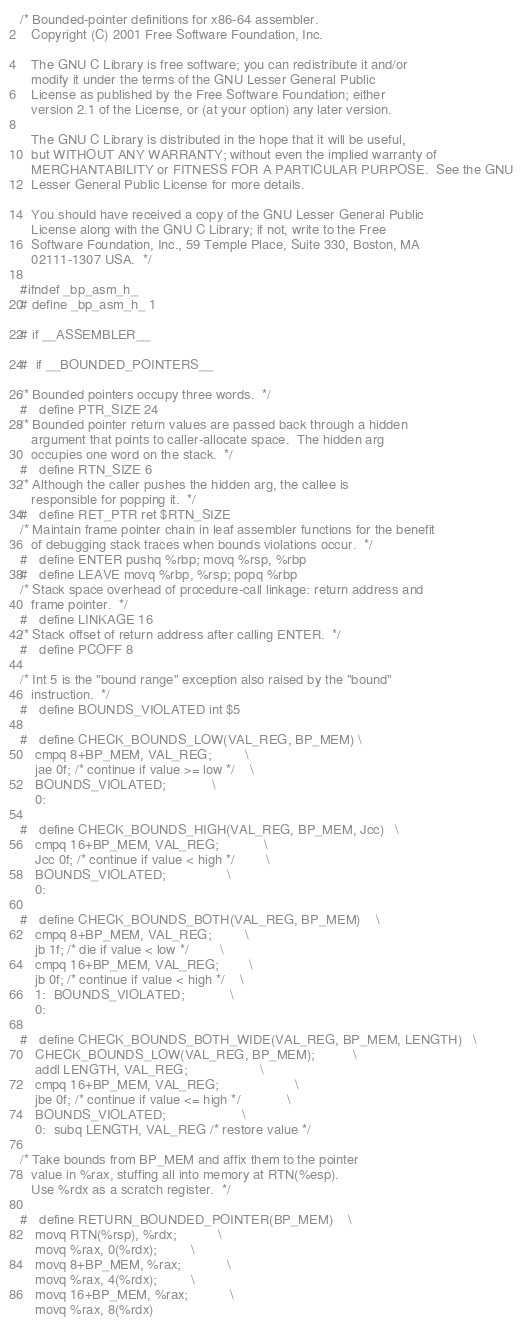Convert code to text. <code><loc_0><loc_0><loc_500><loc_500><_C_>/* Bounded-pointer definitions for x86-64 assembler.
   Copyright (C) 2001 Free Software Foundation, Inc.

   The GNU C Library is free software; you can redistribute it and/or
   modify it under the terms of the GNU Lesser General Public
   License as published by the Free Software Foundation; either
   version 2.1 of the License, or (at your option) any later version.

   The GNU C Library is distributed in the hope that it will be useful,
   but WITHOUT ANY WARRANTY; without even the implied warranty of
   MERCHANTABILITY or FITNESS FOR A PARTICULAR PURPOSE.  See the GNU
   Lesser General Public License for more details.

   You should have received a copy of the GNU Lesser General Public
   License along with the GNU C Library; if not, write to the Free
   Software Foundation, Inc., 59 Temple Place, Suite 330, Boston, MA
   02111-1307 USA.  */

#ifndef _bp_asm_h_
# define _bp_asm_h_ 1

# if __ASSEMBLER__

#  if __BOUNDED_POINTERS__

/* Bounded pointers occupy three words.  */
#   define PTR_SIZE 24
/* Bounded pointer return values are passed back through a hidden
   argument that points to caller-allocate space.  The hidden arg
   occupies one word on the stack.  */
#   define RTN_SIZE 6
/* Although the caller pushes the hidden arg, the callee is
   responsible for popping it.  */
#   define RET_PTR ret $RTN_SIZE
/* Maintain frame pointer chain in leaf assembler functions for the benefit
   of debugging stack traces when bounds violations occur.  */
#   define ENTER pushq %rbp; movq %rsp, %rbp
#   define LEAVE movq %rbp, %rsp; popq %rbp
/* Stack space overhead of procedure-call linkage: return address and
   frame pointer.  */
#   define LINKAGE 16
/* Stack offset of return address after calling ENTER.  */
#   define PCOFF 8

/* Int 5 is the "bound range" exception also raised by the "bound"
   instruction.  */
#   define BOUNDS_VIOLATED int $5

#   define CHECK_BOUNDS_LOW(VAL_REG, BP_MEM)	\
	cmpq 8+BP_MEM, VAL_REG;			\
	jae 0f; /* continue if value >= low */	\
	BOUNDS_VIOLATED;			\
    0:

#   define CHECK_BOUNDS_HIGH(VAL_REG, BP_MEM, Jcc)	\
	cmpq 16+BP_MEM, VAL_REG;			\
	Jcc 0f; /* continue if value < high */		\
	BOUNDS_VIOLATED;				\
    0:

#   define CHECK_BOUNDS_BOTH(VAL_REG, BP_MEM)	\
	cmpq 8+BP_MEM, VAL_REG;			\
	jb 1f; /* die if value < low */		\
	cmpq 16+BP_MEM, VAL_REG;		\
	jb 0f; /* continue if value < high */	\
    1:	BOUNDS_VIOLATED;			\
    0:

#   define CHECK_BOUNDS_BOTH_WIDE(VAL_REG, BP_MEM, LENGTH)	\
	CHECK_BOUNDS_LOW(VAL_REG, BP_MEM);			\
	addl LENGTH, VAL_REG;					\
	cmpq 16+BP_MEM, VAL_REG;					\
	jbe 0f; /* continue if value <= high */			\
	BOUNDS_VIOLATED;					\
    0:	subq LENGTH, VAL_REG /* restore value */

/* Take bounds from BP_MEM and affix them to the pointer
   value in %rax, stuffing all into memory at RTN(%esp).
   Use %rdx as a scratch register.  */

#   define RETURN_BOUNDED_POINTER(BP_MEM)	\
	movq RTN(%rsp), %rdx;			\
	movq %rax, 0(%rdx);			\
	movq 8+BP_MEM, %rax;			\
	movq %rax, 4(%rdx);			\
	movq 16+BP_MEM, %rax;			\
	movq %rax, 8(%rdx)
</code> 